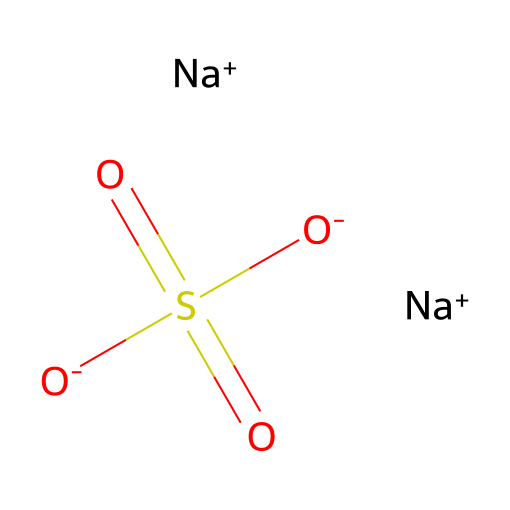What is the central atom of this chemical? The chemical structure indicates that sulfur (S) is the central atom, as it is surrounded by multiple oxygen (O) atoms.
Answer: sulfur How many oxygen atoms are present in the structure? Analyzing the structure, there are four oxygen atoms connected to the sulfur atom.
Answer: four What type of bond connects the sulfur to the oxygen atoms? The sulfur atom forms double bonds to two of the oxygen atoms and single bonds to the other two, indicating the presence of both covalent bonds.
Answer: covalent bonds What is the formal charge of the sulfur atom in this compound? To determine the formal charge, calculate using the formula: Formal Charge = Valence Electrons - (Non-bonding Electrons + 1/2 Bonding Electrons). For sulfur, it has 6 valence electrons and is bonded to 4 oxygen atoms, giving a formal charge of +2.
Answer: +2 What interactions can make this chemical hypervalent? The sulfur atom can exceed the octet rule in bonding by forming bonds with more than eight electrons, thus making it hypervalent. The presence of four oxygen atoms indicates this ability.
Answer: exceeding octet rule What are the likely physiological effects of using this compound in bath salts? The compound may have potential therapeutic effects due to its presence as a sulfur-based salt, which can provide relaxation and stress relief properties when dissolved in water.
Answer: relaxation Why might hypervalent sulfur compounds be preferred in stress-relief bath salts? Hypervalent sulfur compounds can interact favorably with biological systems, enhancing their therapeutic qualities, potentially leading to improved stress relief and relaxation effects.
Answer: therapeutic qualities 